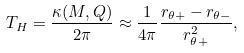<formula> <loc_0><loc_0><loc_500><loc_500>T _ { H } = \frac { \kappa ( M , Q ) } { 2 \pi } \approx \frac { 1 } { 4 \pi } \frac { r _ { \theta + } - r _ { \theta - } } { r ^ { 2 } _ { \theta + } } ,</formula> 